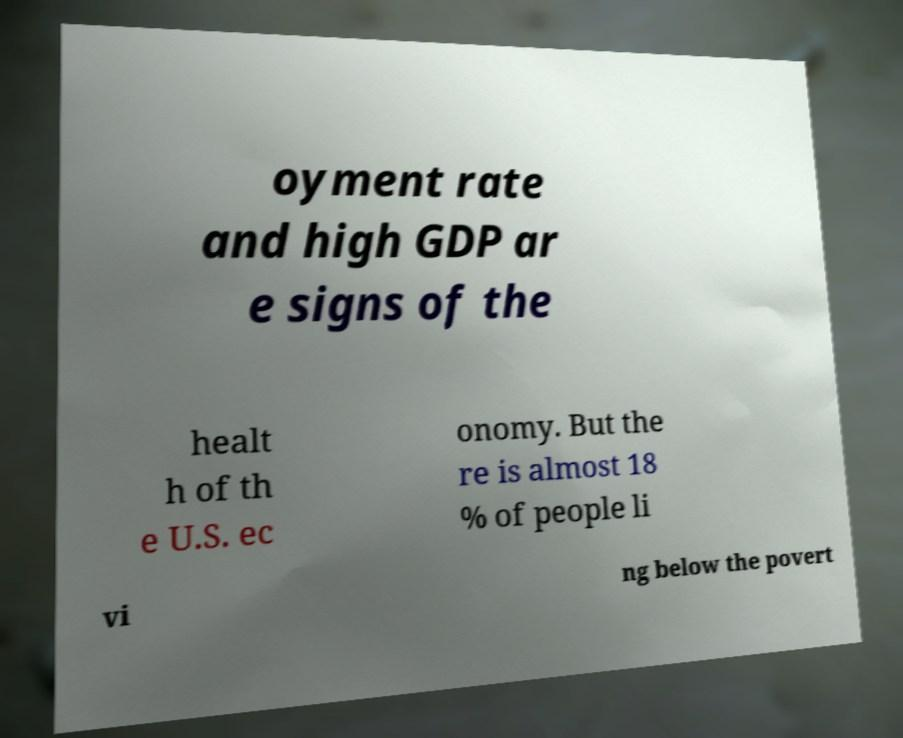What messages or text are displayed in this image? I need them in a readable, typed format. oyment rate and high GDP ar e signs of the healt h of th e U.S. ec onomy. But the re is almost 18 % of people li vi ng below the povert 